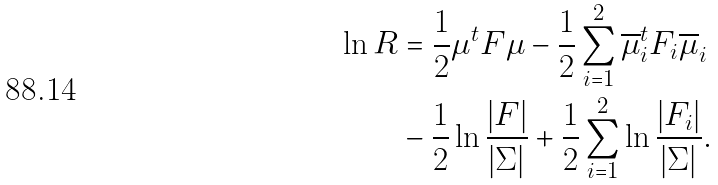<formula> <loc_0><loc_0><loc_500><loc_500>\ln R & = \frac { 1 } { 2 } \mu ^ { t } F \mu - \frac { 1 } { 2 } \sum _ { i = 1 } ^ { 2 } \overline { \mu } _ { i } ^ { t } F _ { i } \overline { \mu } _ { i } \\ & - \frac { 1 } { 2 } \ln \frac { | F | } { | \Sigma | } + \frac { 1 } { 2 } \sum _ { i = 1 } ^ { 2 } \ln \frac { | F _ { i } | } { | \Sigma | } .</formula> 